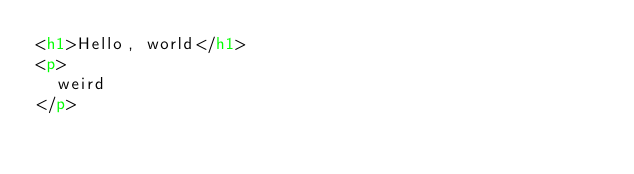Convert code to text. <code><loc_0><loc_0><loc_500><loc_500><_HTML_><h1>Hello, world</h1>
<p>
  weird
</p></code> 